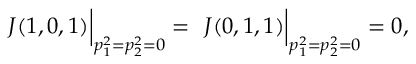<formula> <loc_0><loc_0><loc_500><loc_500>{ } J ( 1 , 0 , 1 ) \right | _ { p _ { 1 } ^ { 2 } = p _ { 2 } ^ { 2 } = 0 } = { } J ( 0 , 1 , 1 ) \right | _ { p _ { 1 } ^ { 2 } = p _ { 2 } ^ { 2 } = 0 } = 0 ,</formula> 